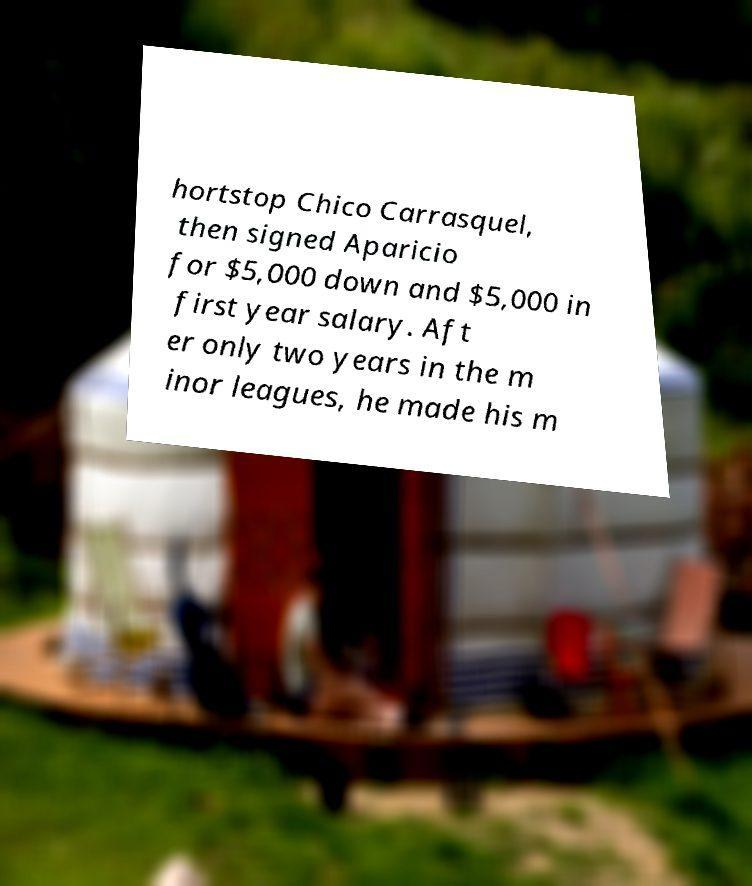Could you assist in decoding the text presented in this image and type it out clearly? hortstop Chico Carrasquel, then signed Aparicio for $5,000 down and $5,000 in first year salary. Aft er only two years in the m inor leagues, he made his m 